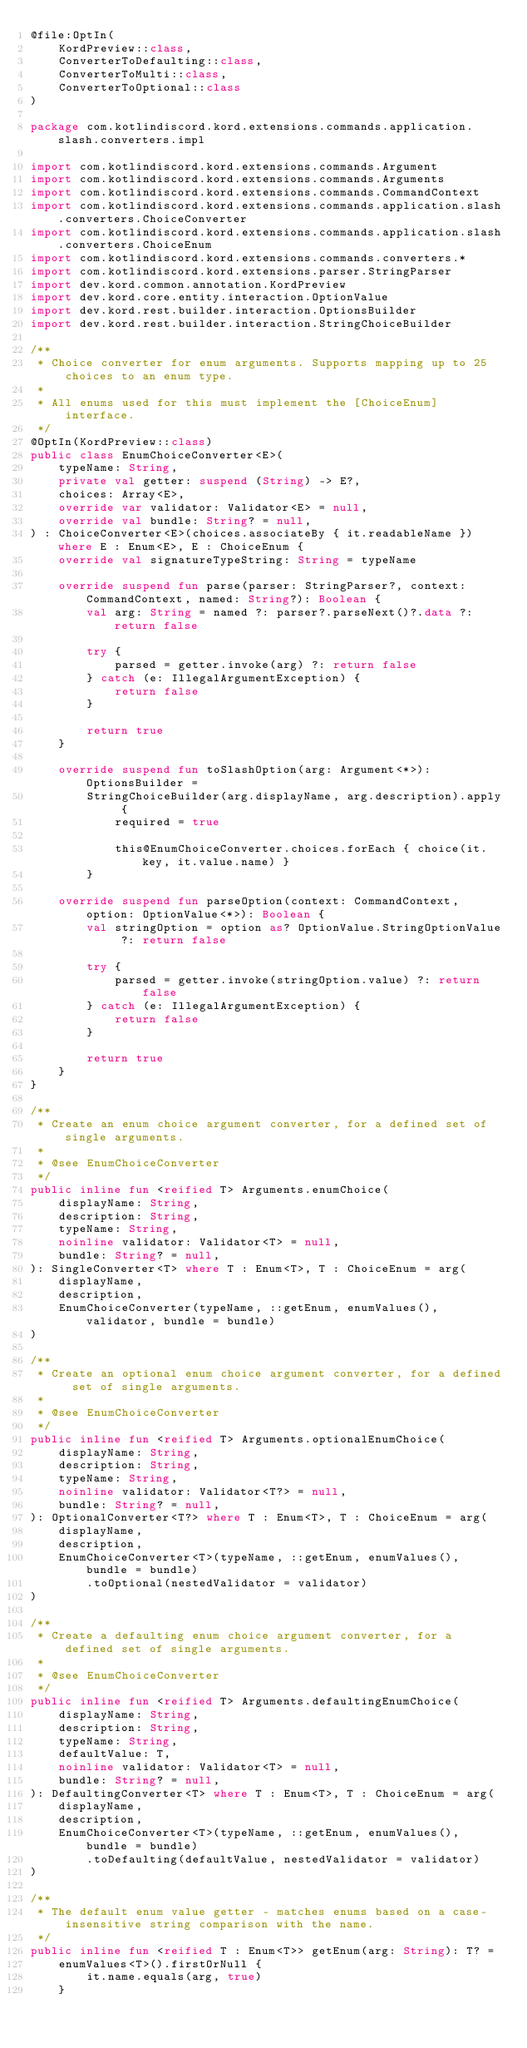<code> <loc_0><loc_0><loc_500><loc_500><_Kotlin_>@file:OptIn(
    KordPreview::class,
    ConverterToDefaulting::class,
    ConverterToMulti::class,
    ConverterToOptional::class
)

package com.kotlindiscord.kord.extensions.commands.application.slash.converters.impl

import com.kotlindiscord.kord.extensions.commands.Argument
import com.kotlindiscord.kord.extensions.commands.Arguments
import com.kotlindiscord.kord.extensions.commands.CommandContext
import com.kotlindiscord.kord.extensions.commands.application.slash.converters.ChoiceConverter
import com.kotlindiscord.kord.extensions.commands.application.slash.converters.ChoiceEnum
import com.kotlindiscord.kord.extensions.commands.converters.*
import com.kotlindiscord.kord.extensions.parser.StringParser
import dev.kord.common.annotation.KordPreview
import dev.kord.core.entity.interaction.OptionValue
import dev.kord.rest.builder.interaction.OptionsBuilder
import dev.kord.rest.builder.interaction.StringChoiceBuilder

/**
 * Choice converter for enum arguments. Supports mapping up to 25 choices to an enum type.
 *
 * All enums used for this must implement the [ChoiceEnum] interface.
 */
@OptIn(KordPreview::class)
public class EnumChoiceConverter<E>(
    typeName: String,
    private val getter: suspend (String) -> E?,
    choices: Array<E>,
    override var validator: Validator<E> = null,
    override val bundle: String? = null,
) : ChoiceConverter<E>(choices.associateBy { it.readableName }) where E : Enum<E>, E : ChoiceEnum {
    override val signatureTypeString: String = typeName

    override suspend fun parse(parser: StringParser?, context: CommandContext, named: String?): Boolean {
        val arg: String = named ?: parser?.parseNext()?.data ?: return false

        try {
            parsed = getter.invoke(arg) ?: return false
        } catch (e: IllegalArgumentException) {
            return false
        }

        return true
    }

    override suspend fun toSlashOption(arg: Argument<*>): OptionsBuilder =
        StringChoiceBuilder(arg.displayName, arg.description).apply {
            required = true

            this@EnumChoiceConverter.choices.forEach { choice(it.key, it.value.name) }
        }

    override suspend fun parseOption(context: CommandContext, option: OptionValue<*>): Boolean {
        val stringOption = option as? OptionValue.StringOptionValue ?: return false

        try {
            parsed = getter.invoke(stringOption.value) ?: return false
        } catch (e: IllegalArgumentException) {
            return false
        }

        return true
    }
}

/**
 * Create an enum choice argument converter, for a defined set of single arguments.
 *
 * @see EnumChoiceConverter
 */
public inline fun <reified T> Arguments.enumChoice(
    displayName: String,
    description: String,
    typeName: String,
    noinline validator: Validator<T> = null,
    bundle: String? = null,
): SingleConverter<T> where T : Enum<T>, T : ChoiceEnum = arg(
    displayName,
    description,
    EnumChoiceConverter(typeName, ::getEnum, enumValues(), validator, bundle = bundle)
)

/**
 * Create an optional enum choice argument converter, for a defined set of single arguments.
 *
 * @see EnumChoiceConverter
 */
public inline fun <reified T> Arguments.optionalEnumChoice(
    displayName: String,
    description: String,
    typeName: String,
    noinline validator: Validator<T?> = null,
    bundle: String? = null,
): OptionalConverter<T?> where T : Enum<T>, T : ChoiceEnum = arg(
    displayName,
    description,
    EnumChoiceConverter<T>(typeName, ::getEnum, enumValues(), bundle = bundle)
        .toOptional(nestedValidator = validator)
)

/**
 * Create a defaulting enum choice argument converter, for a defined set of single arguments.
 *
 * @see EnumChoiceConverter
 */
public inline fun <reified T> Arguments.defaultingEnumChoice(
    displayName: String,
    description: String,
    typeName: String,
    defaultValue: T,
    noinline validator: Validator<T> = null,
    bundle: String? = null,
): DefaultingConverter<T> where T : Enum<T>, T : ChoiceEnum = arg(
    displayName,
    description,
    EnumChoiceConverter<T>(typeName, ::getEnum, enumValues(), bundle = bundle)
        .toDefaulting(defaultValue, nestedValidator = validator)
)

/**
 * The default enum value getter - matches enums based on a case-insensitive string comparison with the name.
 */
public inline fun <reified T : Enum<T>> getEnum(arg: String): T? =
    enumValues<T>().firstOrNull {
        it.name.equals(arg, true)
    }
</code> 